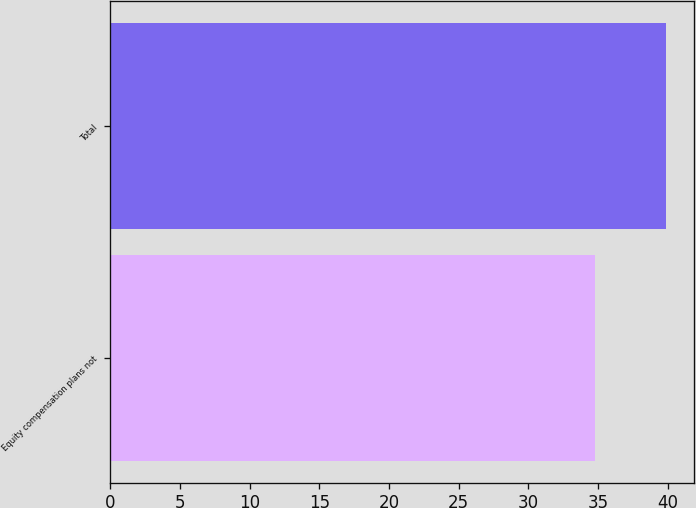Convert chart. <chart><loc_0><loc_0><loc_500><loc_500><bar_chart><fcel>Equity compensation plans not<fcel>Total<nl><fcel>34.77<fcel>39.91<nl></chart> 